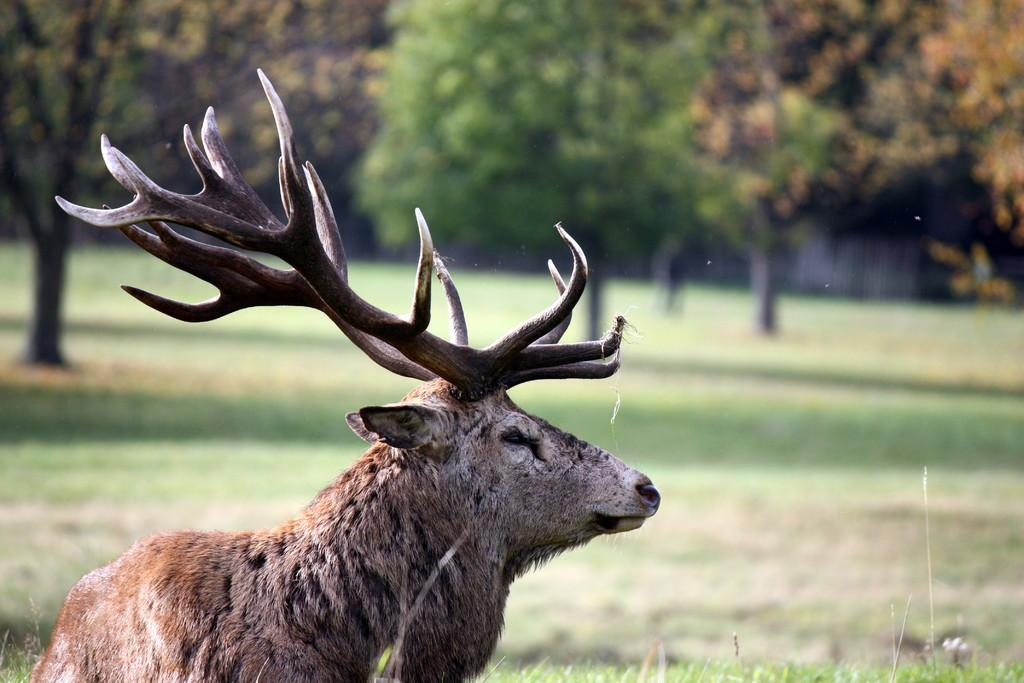What type of vegetation is present in the image? There is grass in the image. What can be seen on the left side of the image? There is an animal on the left side of the image. What is visible in the background of the image? There are trees visible in the background of the image. What type of scissors can be seen in the image? There are no scissors present in the image. What disease is affecting the animal in the image? There is no indication of any disease affecting the animal in the image. 